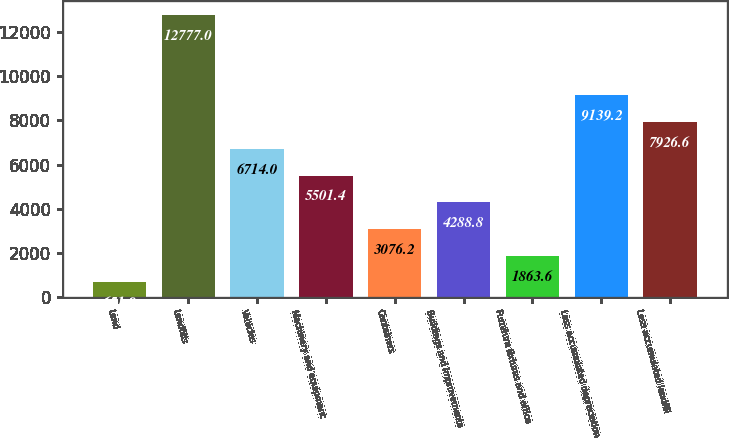Convert chart. <chart><loc_0><loc_0><loc_500><loc_500><bar_chart><fcel>Land<fcel>Landfills<fcel>Vehicles<fcel>Machinery and equipment<fcel>Containers<fcel>Buildings and improvements<fcel>Furniture fixtures and office<fcel>Less accumulated depreciation<fcel>Less accumulated landfill<nl><fcel>651<fcel>12777<fcel>6714<fcel>5501.4<fcel>3076.2<fcel>4288.8<fcel>1863.6<fcel>9139.2<fcel>7926.6<nl></chart> 